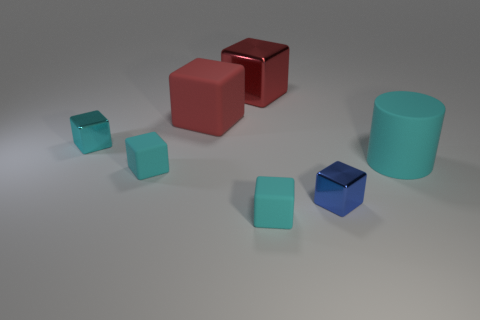Subtract all yellow spheres. How many cyan blocks are left? 3 Add 1 small yellow shiny cylinders. How many objects exist? 8 Subtract all large red cubes. How many cubes are left? 4 Subtract all cyan cubes. How many cubes are left? 3 Subtract 1 cubes. How many cubes are left? 5 Subtract all cubes. How many objects are left? 1 Subtract all small objects. Subtract all large red cubes. How many objects are left? 1 Add 1 tiny blue shiny objects. How many tiny blue shiny objects are left? 2 Add 3 blue shiny objects. How many blue shiny objects exist? 4 Subtract 0 green cubes. How many objects are left? 7 